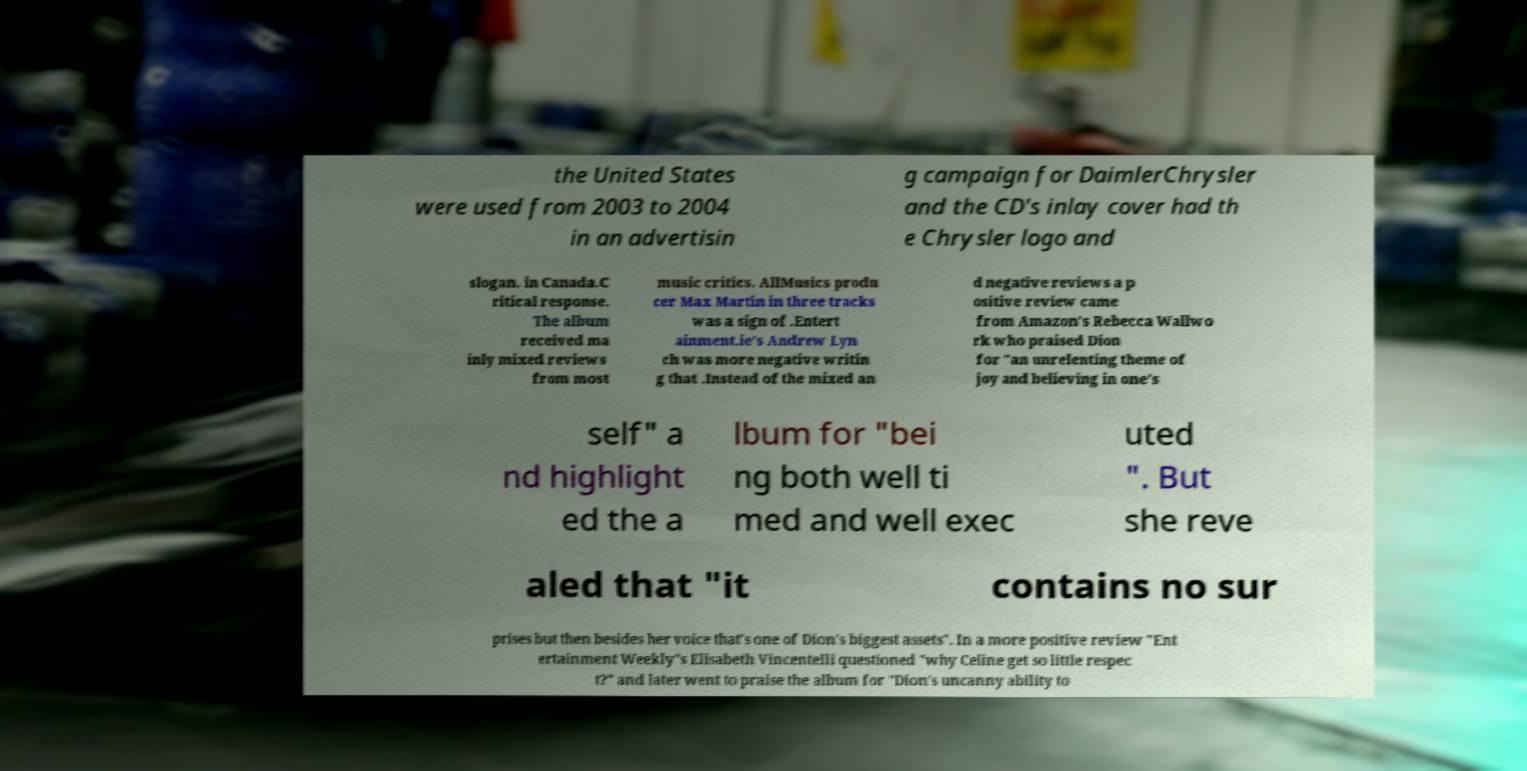Can you accurately transcribe the text from the provided image for me? the United States were used from 2003 to 2004 in an advertisin g campaign for DaimlerChrysler and the CD's inlay cover had th e Chrysler logo and slogan. in Canada.C ritical response. The album received ma inly mixed reviews from most music critics. AllMusics produ cer Max Martin in three tracks was a sign of .Entert ainment.ie's Andrew Lyn ch was more negative writin g that .Instead of the mixed an d negative reviews a p ositive review came from Amazon's Rebecca Wallwo rk who praised Dion for "an unrelenting theme of joy and believing in one's self" a nd highlight ed the a lbum for "bei ng both well ti med and well exec uted ". But she reve aled that "it contains no sur prises but then besides her voice that's one of Dion's biggest assets". In a more positive review "Ent ertainment Weekly"s Elisabeth Vincentelli questioned "why Celine get so little respec t?" and later went to praise the album for "Dion's uncanny ability to 